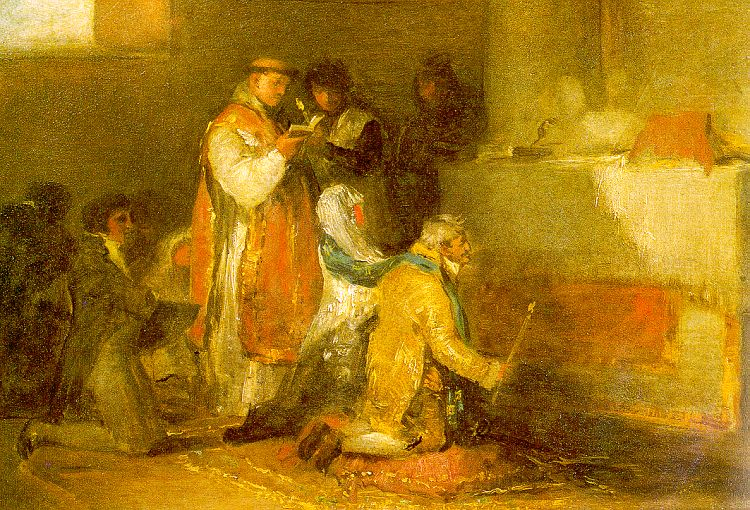Let's take a very creative approach! What if these individuals were part of a secret society? What could they be planning? Imagine the figures in this painting as members of a clandestine society, gathered in secrecy under the guise of a routine prayer session. The person in the red robe could be the society's leader, reading out a cryptic message or a set of coded instructions. The individual kneeling could be pledging their loyalty or receiving a crucial assignment for the society's larger mission. The warm, inviting atmosphere disguises the intensity of their covert planning, and each color and stroke hides a symbol or hidden clue about their true intentions. Perhaps they are plotting to protect an ancient artifact or orchestrating a larger move in the political landscape of their time. 